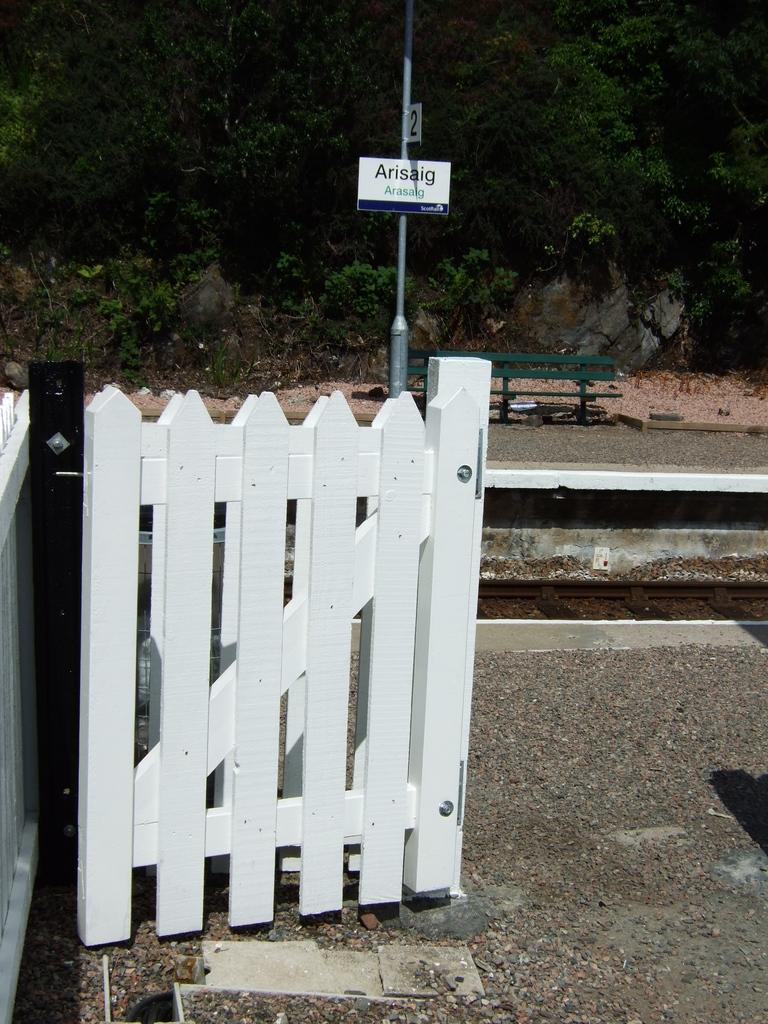How would you summarize this image in a sentence or two? In this image, there is an outside view. There is a gate in the middle of the image. There is a track on the right side of the image. There is a bench and pole in the middle of the image. 